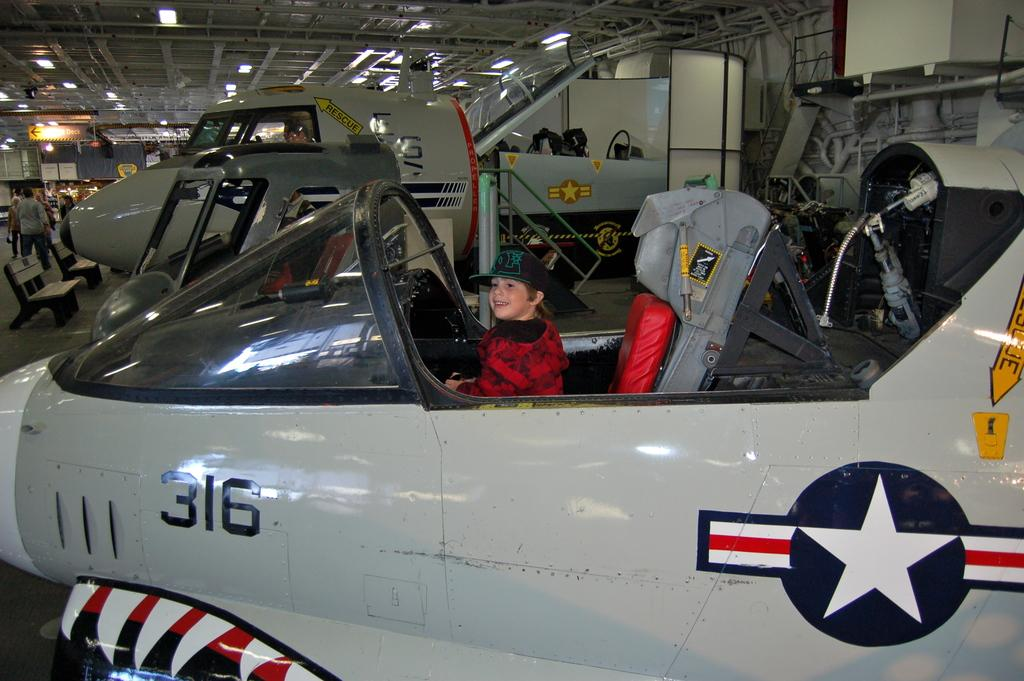<image>
Describe the image concisely. a boy is sitting inside an airplane numbered 316 in a museum 